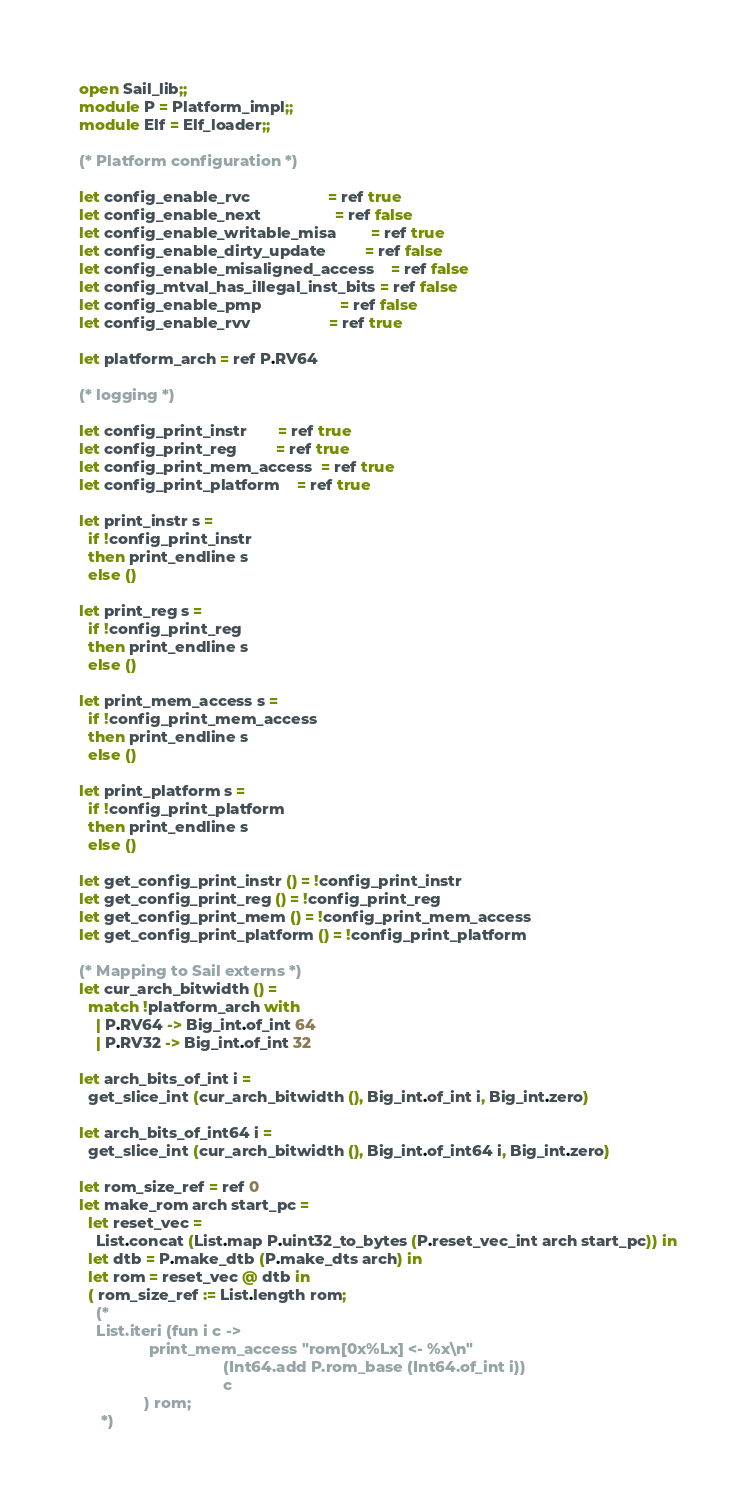Convert code to text. <code><loc_0><loc_0><loc_500><loc_500><_OCaml_>open Sail_lib;;
module P = Platform_impl;;
module Elf = Elf_loader;;

(* Platform configuration *)

let config_enable_rvc                  = ref true
let config_enable_next                 = ref false
let config_enable_writable_misa        = ref true
let config_enable_dirty_update         = ref false
let config_enable_misaligned_access    = ref false
let config_mtval_has_illegal_inst_bits = ref false
let config_enable_pmp                  = ref false
let config_enable_rvv                  = ref true

let platform_arch = ref P.RV64

(* logging *)

let config_print_instr       = ref true
let config_print_reg         = ref true
let config_print_mem_access  = ref true
let config_print_platform    = ref true

let print_instr s =
  if !config_print_instr
  then print_endline s
  else ()

let print_reg s =
  if !config_print_reg
  then print_endline s
  else ()

let print_mem_access s =
  if !config_print_mem_access
  then print_endline s
  else ()

let print_platform s =
  if !config_print_platform
  then print_endline s
  else ()

let get_config_print_instr () = !config_print_instr
let get_config_print_reg () = !config_print_reg
let get_config_print_mem () = !config_print_mem_access
let get_config_print_platform () = !config_print_platform

(* Mapping to Sail externs *)
let cur_arch_bitwidth () =
  match !platform_arch with
    | P.RV64 -> Big_int.of_int 64
    | P.RV32 -> Big_int.of_int 32

let arch_bits_of_int i =
  get_slice_int (cur_arch_bitwidth (), Big_int.of_int i, Big_int.zero)

let arch_bits_of_int64 i =
  get_slice_int (cur_arch_bitwidth (), Big_int.of_int64 i, Big_int.zero)

let rom_size_ref = ref 0
let make_rom arch start_pc =
  let reset_vec =
    List.concat (List.map P.uint32_to_bytes (P.reset_vec_int arch start_pc)) in
  let dtb = P.make_dtb (P.make_dts arch) in
  let rom = reset_vec @ dtb in
  ( rom_size_ref := List.length rom;
    (*
    List.iteri (fun i c ->
                print_mem_access "rom[0x%Lx] <- %x\n"
                                 (Int64.add P.rom_base (Int64.of_int i))
                                 c
               ) rom;
     *)</code> 